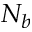<formula> <loc_0><loc_0><loc_500><loc_500>N _ { b }</formula> 